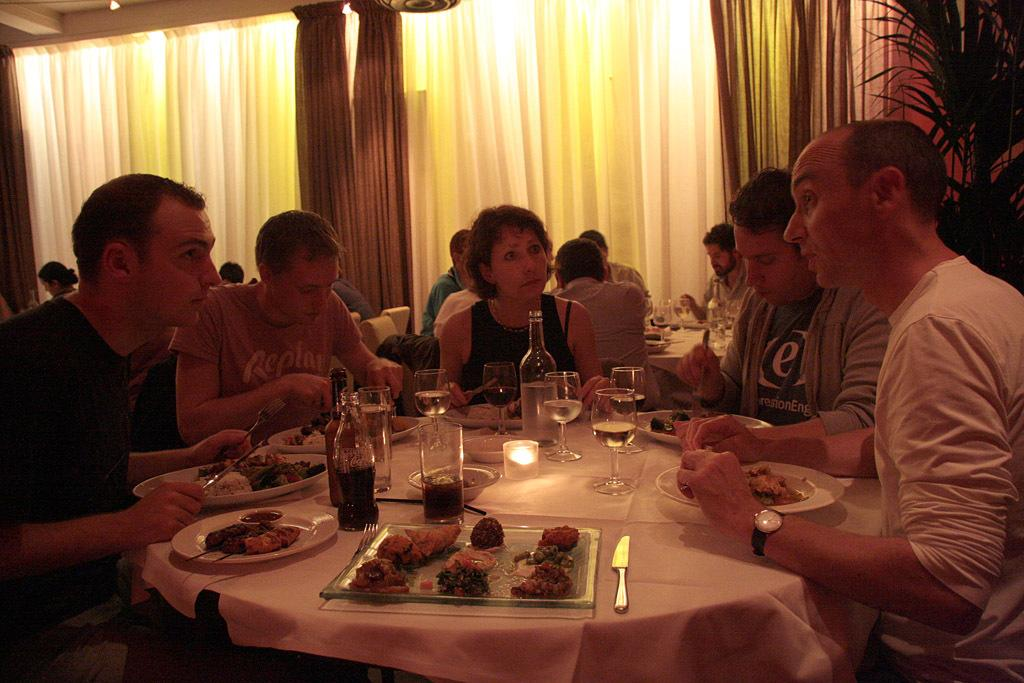What are the people in the image doing? The people in the image are sitting around a table and eating food. What beverage is being served in the glasses on the table? There are glasses with wine on the table. Can you describe the object behind the people? There is a bottle behind the people. What can be seen in the background of the image? There is a curtain and a plant in the background. How many trucks are parked outside the window in the image? There are no trucks visible in the image; it only shows people sitting around a table with food and wine. What level of expertise do the people have in playing a musical instrument in the image? There is no indication of any musical instruments or playing in the image. 